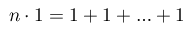<formula> <loc_0><loc_0><loc_500><loc_500>n \cdot 1 = 1 + 1 + \dots + 1</formula> 